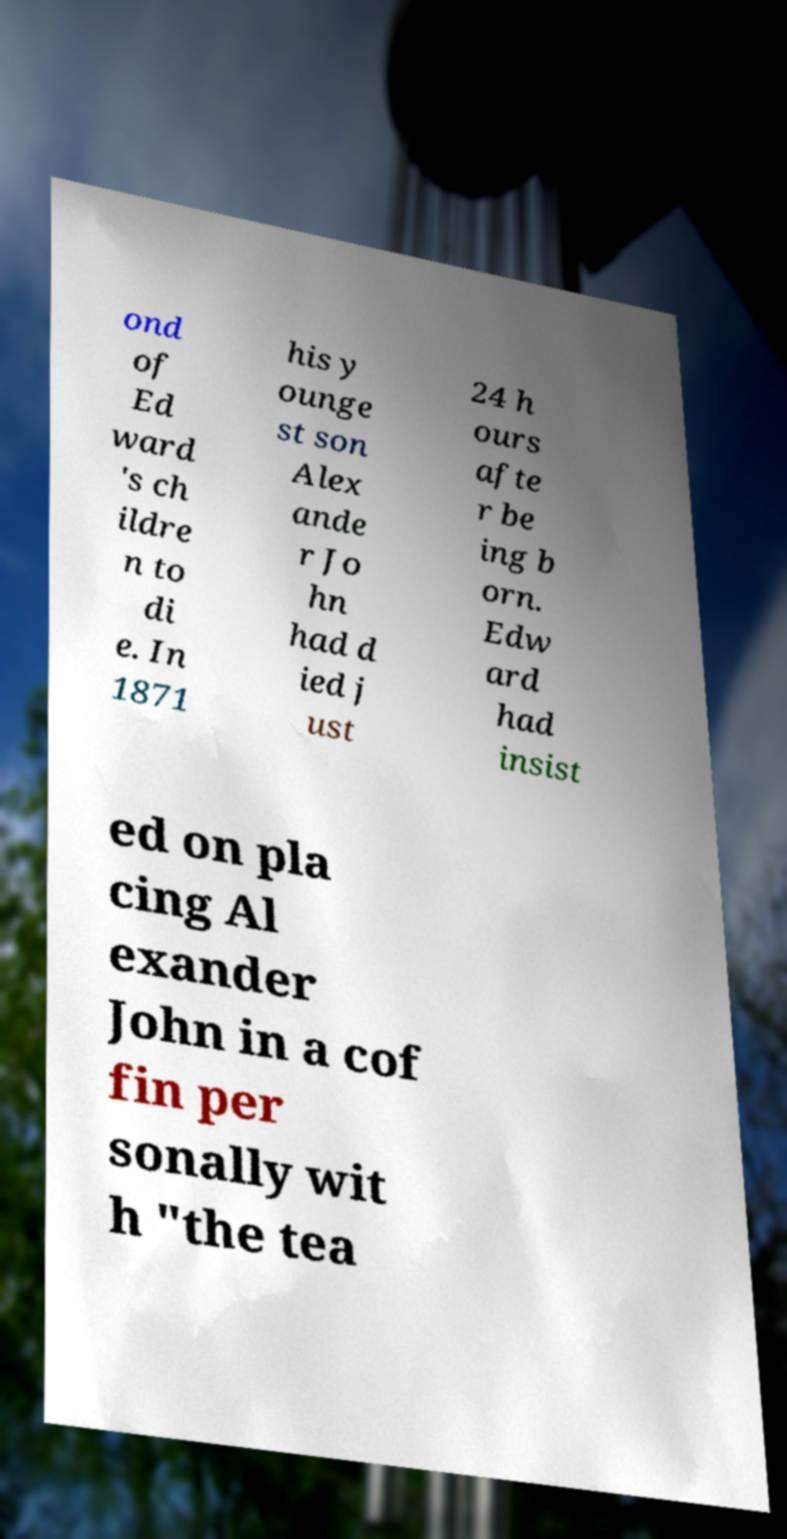For documentation purposes, I need the text within this image transcribed. Could you provide that? ond of Ed ward 's ch ildre n to di e. In 1871 his y ounge st son Alex ande r Jo hn had d ied j ust 24 h ours afte r be ing b orn. Edw ard had insist ed on pla cing Al exander John in a cof fin per sonally wit h "the tea 